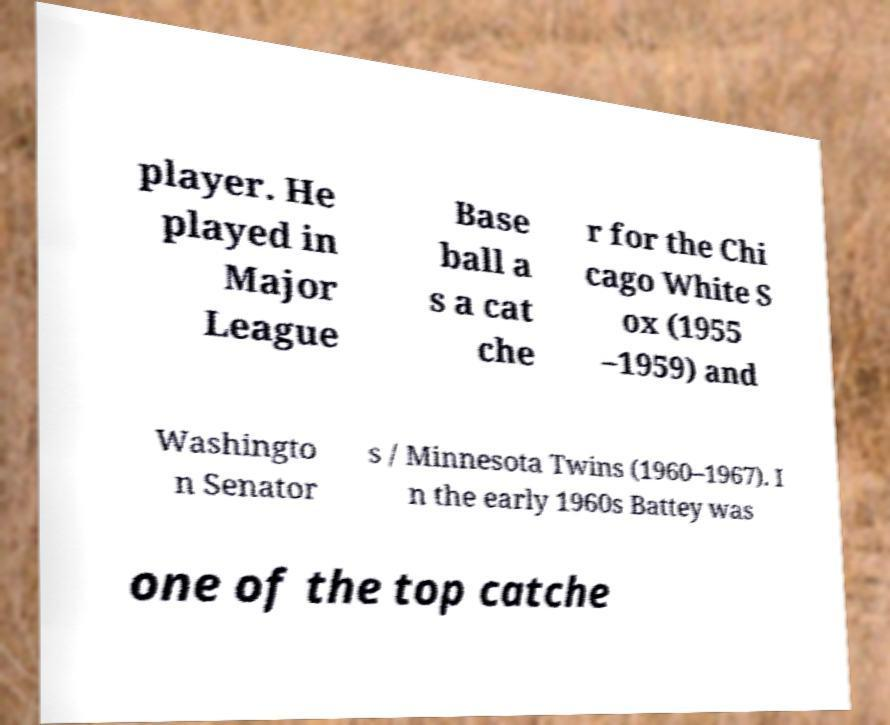Can you accurately transcribe the text from the provided image for me? player. He played in Major League Base ball a s a cat che r for the Chi cago White S ox (1955 –1959) and Washingto n Senator s / Minnesota Twins (1960–1967). I n the early 1960s Battey was one of the top catche 